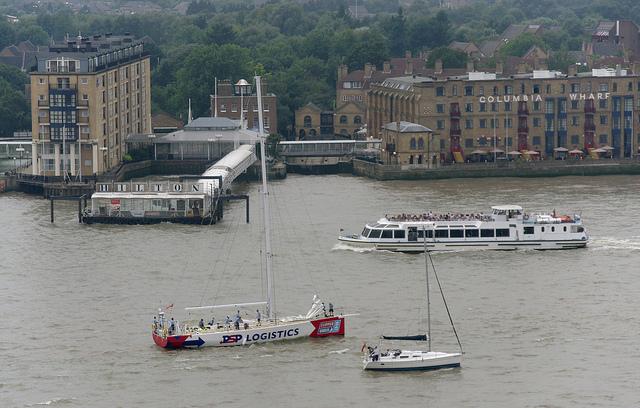Is this a toy harbor?
Keep it brief. No. Is it raining?
Quick response, please. No. Is there a reflection?
Be succinct. No. Are there passengers on the boats?
Be succinct. Yes. Is this a tourist attraction?
Keep it brief. Yes. What type of boat does this resemble?
Give a very brief answer. Ferry. Is the water darker near the closest boats?
Be succinct. No. How many boats are there?
Concise answer only. 3. Are these boats racing?
Quick response, please. No. What is the main color of the boat?
Keep it brief. White. What color are the boats?
Keep it brief. White. How many boats are in the water?
Give a very brief answer. 3. Do the boats pull right up to buildings?
Answer briefly. Yes. What color is the boat's sail?
Answer briefly. White. Are the boats docked?
Quick response, please. No. Does the water appear calm?
Quick response, please. Yes. 